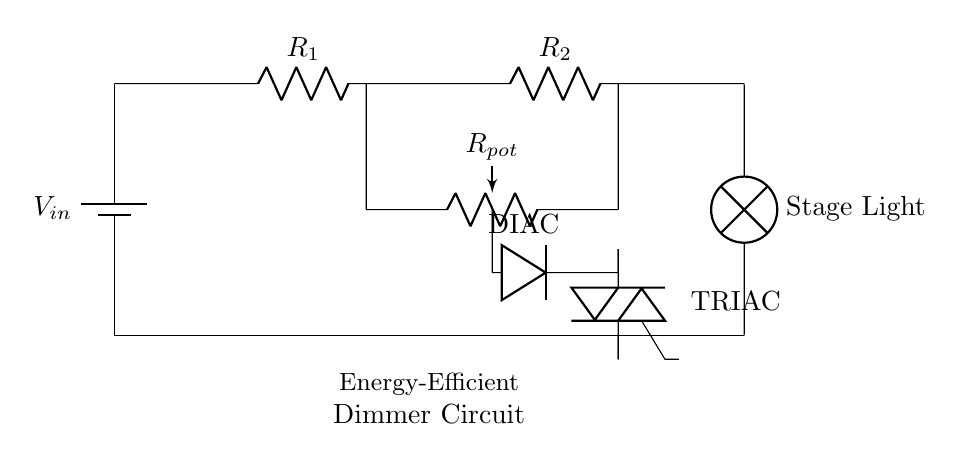What is the main component used to adjust the light intensity? The main component for adjusting light intensity in this dimmer circuit is the potentiometer (R_pot), which allows variable resistance to control the current flowing to the lamp.
Answer: potentiometer What type of device is the component labeled "DIAC"? The component labeled "DIAC" is a type of semiconductor device that allows current to flow only after a certain breakdown voltage is reached, typically used in dimming applications.
Answer: Semiconductor How many resistors are present in this circuit? There are two resistors in this circuit, labeled as R1 and R2, which help in controlling the current through the stage light.
Answer: two What is the purpose of the TRIAC in this circuit? The TRIAC acts as a switch that can control the power delivered to the lamp by allowing current to flow when triggered by the DIAC, which is essential for the dimming functionality.
Answer: switch What does the "lamp" symbolize in this circuit diagram? The "lamp" represents the stage light that is being controlled by the dimmer circuit, serving as the load where the adjusted voltage is applied.
Answer: Stage Light At which point in the circuit does the current leave the TRIAC? The current leaves the TRIAC at the lower terminal connecting to the lamp, allowing the adjusted power to reach the stage light.
Answer: lower terminal What would happen if the R_pot is set to the minimum resistance? If R_pot is set to minimum resistance, the current would be maximal, leading to the brightest output of the stage light since more current would flow through the lamp.
Answer: Brightest output 